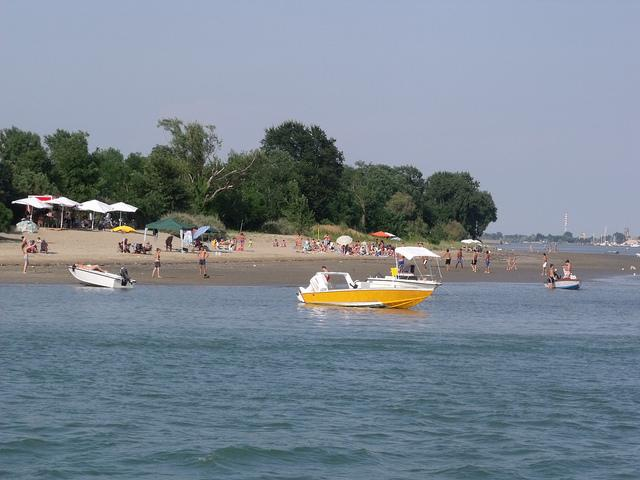What energy moves these boats?

Choices:
A) manual force
B) diesel
C) electricity
D) gas electricity 